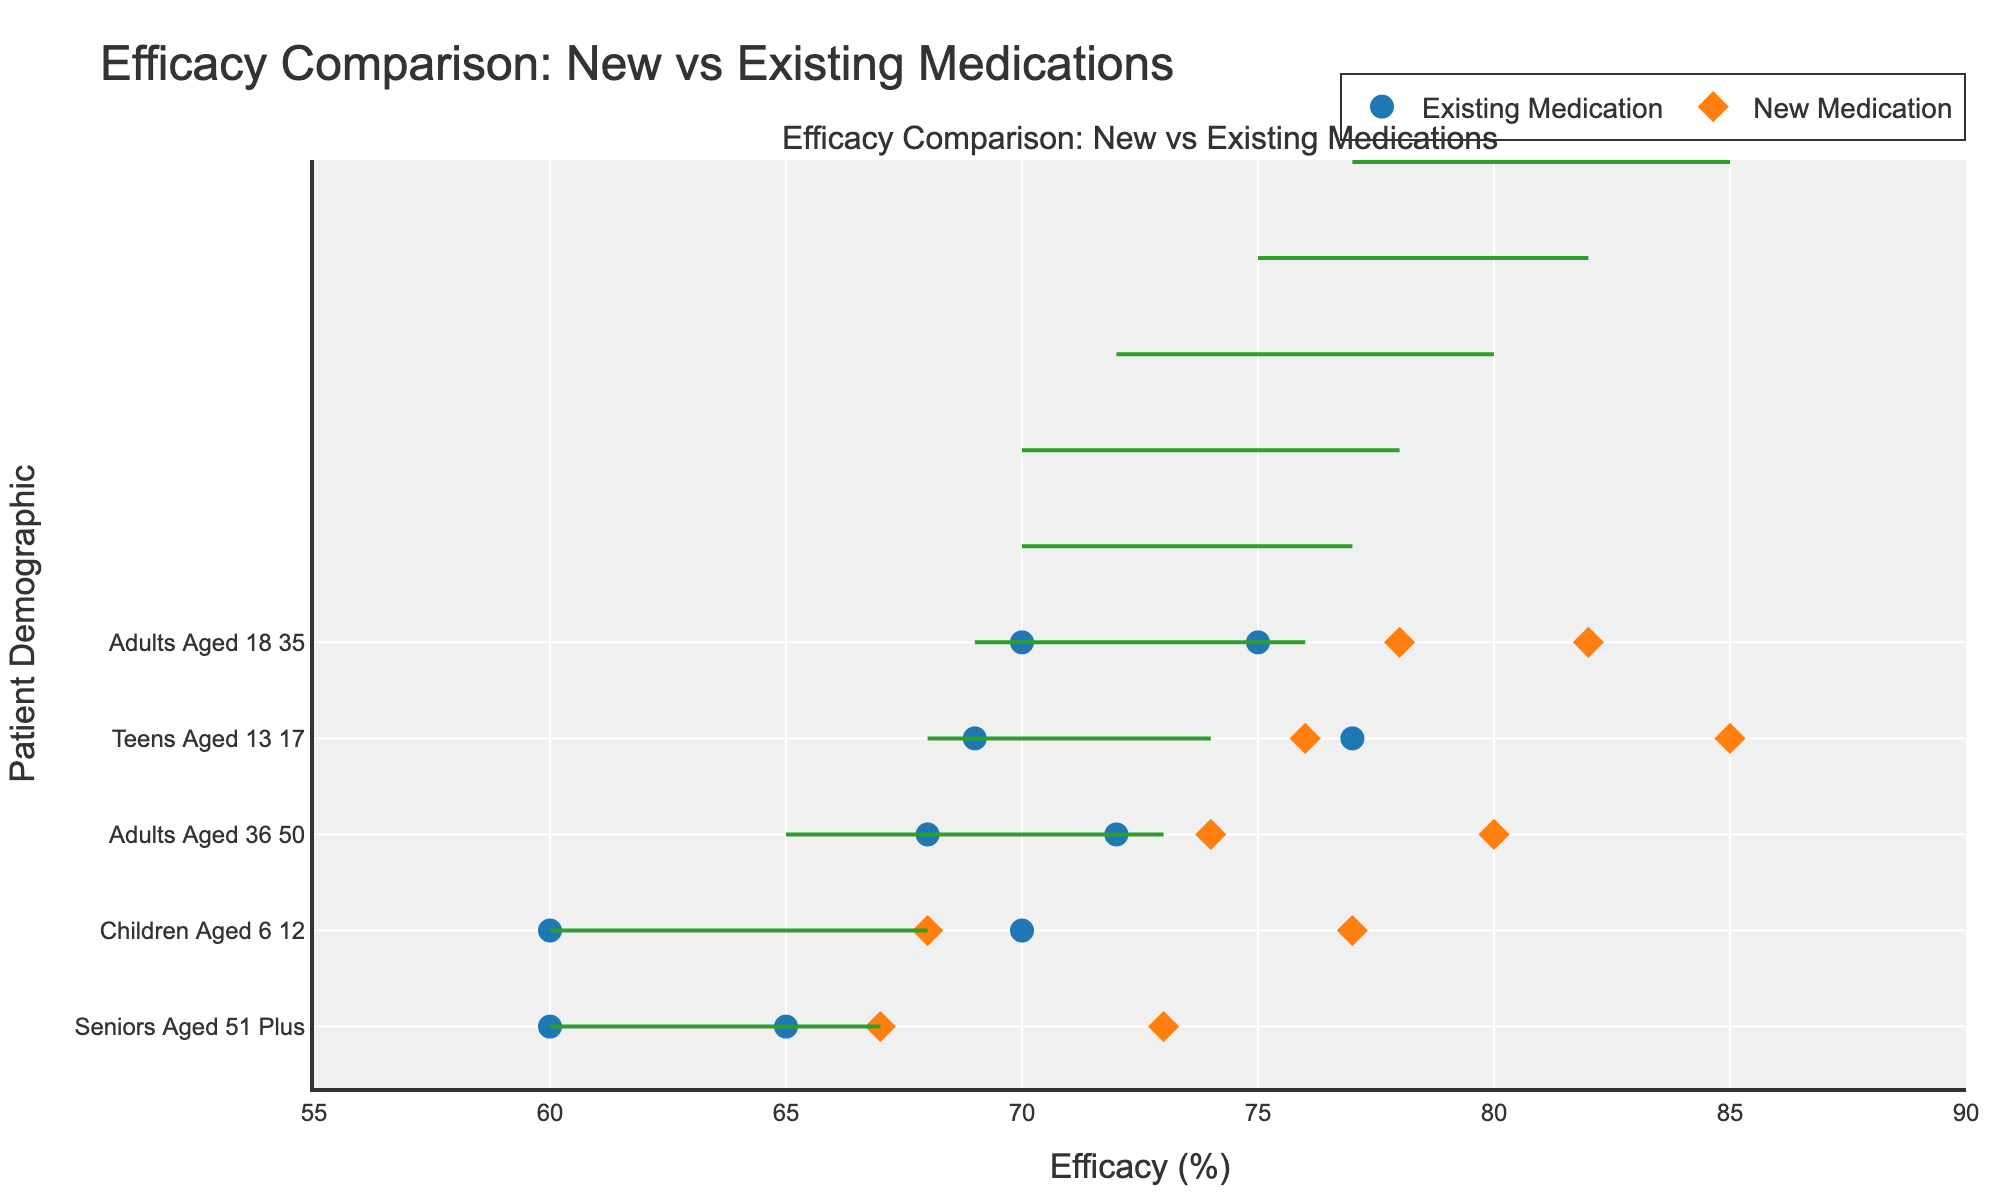Which patient demographic shows the highest increase in efficacy with the new medication? By looking at the distance between the markers for existing and new medications within each demographic, the longest line indicates the highest increase in efficacy. For Teens Aged 13-17, the increase in efficacy of Ibuprofen is the largest.
Answer: Teens Aged 13-17 What is the title of the plot? The title of the plot is displayed at the top-center of the figure.
Answer: Efficacy Comparison: New vs Existing Medications How many patient demographics are displayed in the plot? Count the distinct entries along the y-axis, which represent the different patient demographics. There are eight demographics listed on the y-axis.
Answer: 8 Which new medication shows the highest efficacy, and what is its value? By comparing the positions of the markers for new medications along the x-axis, the farthest marker to the right indicates the highest efficacy. The highest efficacy is for Ibuprofen Optimized for Teens Aged 13-17 at 85%.
Answer: Ibuprofen Optimized, 85% What is the average efficacy of existing medications for Adults Aged 36-50? The two efficacy values for existing medications in this demographic are Naproxen (68%) and Aspirin (72%). Calculate the average: (68 + 72) / 2 = 70%.
Answer: 70% Which medication demonstrates the smallest improvement in efficacy for Seniors Aged 51 Plus? Compare the distances between markers for existing and new medications within the demographic. Diclofenac shows a smaller improvement from 60% to 67% as compared to Acetaminophen's improvement from 65% to 73%.
Answer: Diclofenac What is the range of efficacy values for existing medications across all demographics? Identify the minimum and maximum values of existing medication efficacies. The minimum existing efficacy is 60% (Diclofenac for Seniors Aged 51 Plus and Acetaminophen for Children Aged 6-12), and the maximum is 77% (Ibuprofen for Teens Aged 13-17).
Answer: 60% to 77% Which combination of demographic and medication shows the lowest efficacy for new medications? By finding the lowest marker on the x-axis for new medications, Diclofenac Improved for Seniors Aged 51 Plus at 67% is identified as the lowest efficacy.
Answer: Seniors Aged 51 Plus, Diclofenac Improved How many different types of medications are compared in the plot? Count all the unique medication names (both existing and new) across the data set. There are ten unique medications: Ibuprofen, Ibuprofen Optimized, Paracetamol, Paracetamol Enhanced, Naproxen, Naproxen Optimized, Aspirin, Aspirin Advanced, Acetaminophen, Acetaminophen Plus, Diclofenac, Diclofenac Improved.
Answer: 12 